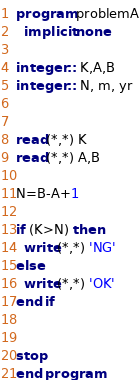Convert code to text. <code><loc_0><loc_0><loc_500><loc_500><_FORTRAN_>program problemA
  implicit none

integer :: K,A,B
integer :: N, m, yr


read(*,*) K
read(*,*) A,B

N=B-A+1

if (K>N) then
  write(*,*) 'NG'
else
  write(*,*) 'OK'
end if


stop
end program
</code> 